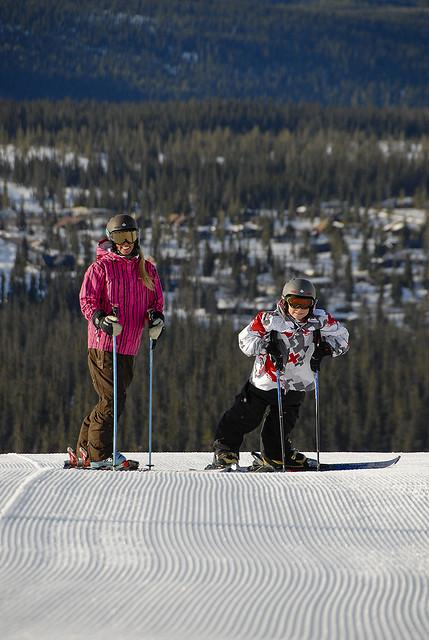What color are the vertical stripes on the left skier's jacket? black 